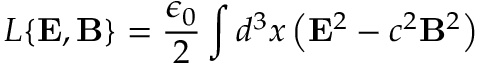Convert formula to latex. <formula><loc_0><loc_0><loc_500><loc_500>L \{ { E } , { B } \} = \frac { \epsilon _ { 0 } } { 2 } \int d ^ { 3 } x \left ( { E } ^ { 2 } - c ^ { 2 } { B } ^ { 2 } \right )</formula> 